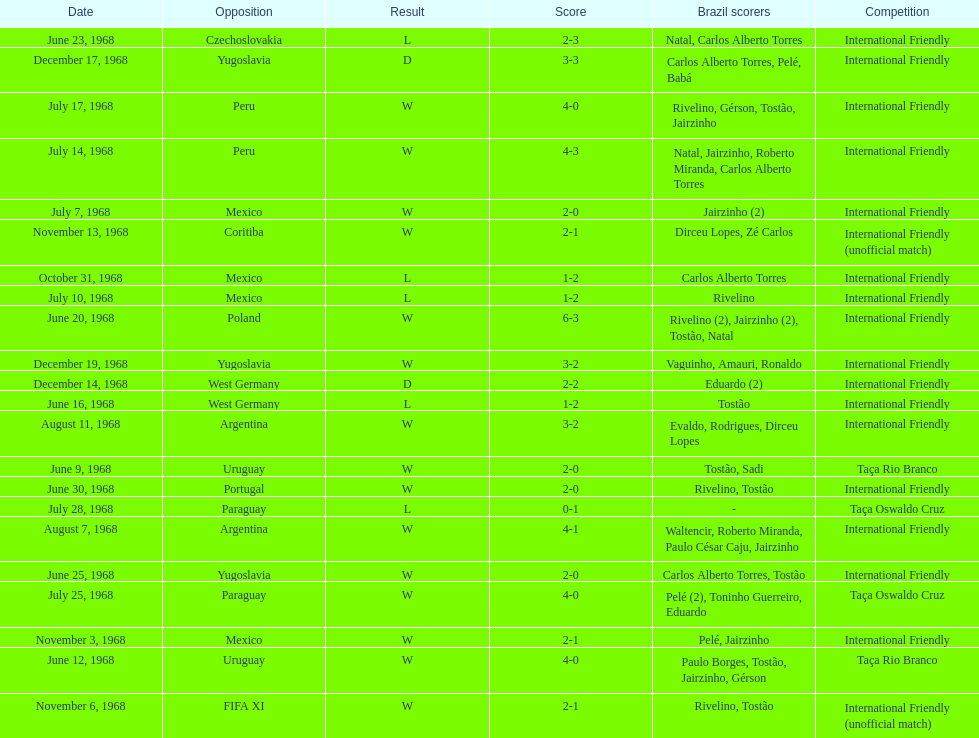Name the first competition ever played by brazil. Taça Rio Branco. 